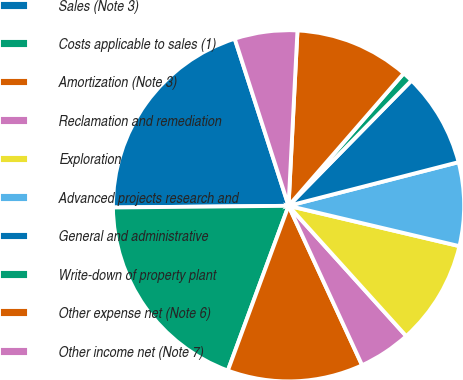<chart> <loc_0><loc_0><loc_500><loc_500><pie_chart><fcel>Sales (Note 3)<fcel>Costs applicable to sales (1)<fcel>Amortization (Note 3)<fcel>Reclamation and remediation<fcel>Exploration<fcel>Advanced projects research and<fcel>General and administrative<fcel>Write-down of property plant<fcel>Other expense net (Note 6)<fcel>Other income net (Note 7)<nl><fcel>20.19%<fcel>19.23%<fcel>12.5%<fcel>4.81%<fcel>9.62%<fcel>7.69%<fcel>8.65%<fcel>0.96%<fcel>10.58%<fcel>5.77%<nl></chart> 